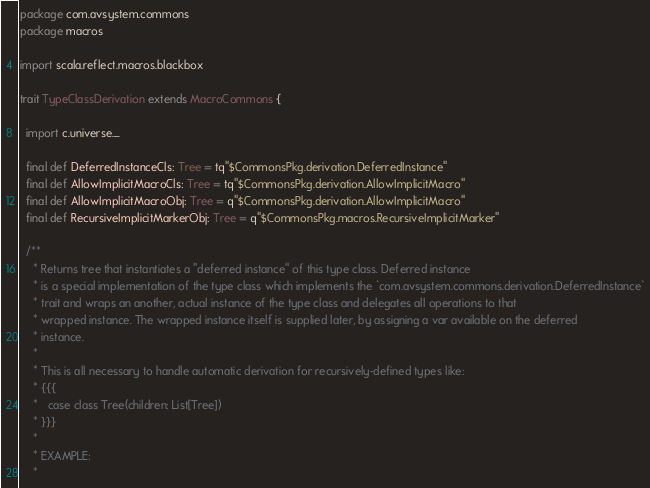Convert code to text. <code><loc_0><loc_0><loc_500><loc_500><_Scala_>package com.avsystem.commons
package macros

import scala.reflect.macros.blackbox

trait TypeClassDerivation extends MacroCommons {

  import c.universe._

  final def DeferredInstanceCls: Tree = tq"$CommonsPkg.derivation.DeferredInstance"
  final def AllowImplicitMacroCls: Tree = tq"$CommonsPkg.derivation.AllowImplicitMacro"
  final def AllowImplicitMacroObj: Tree = q"$CommonsPkg.derivation.AllowImplicitMacro"
  final def RecursiveImplicitMarkerObj: Tree = q"$CommonsPkg.macros.RecursiveImplicitMarker"

  /**
    * Returns tree that instantiates a "deferred instance" of this type class. Deferred instance
    * is a special implementation of the type class which implements the `com.avsystem.commons.derivation.DeferredInstance`
    * trait and wraps an another, actual instance of the type class and delegates all operations to that
    * wrapped instance. The wrapped instance itself is supplied later, by assigning a var available on the deferred
    * instance.
    *
    * This is all necessary to handle automatic derivation for recursively-defined types like:
    * {{{
    *   case class Tree(children: List[Tree])
    * }}}
    *
    * EXAMPLE:
    *</code> 